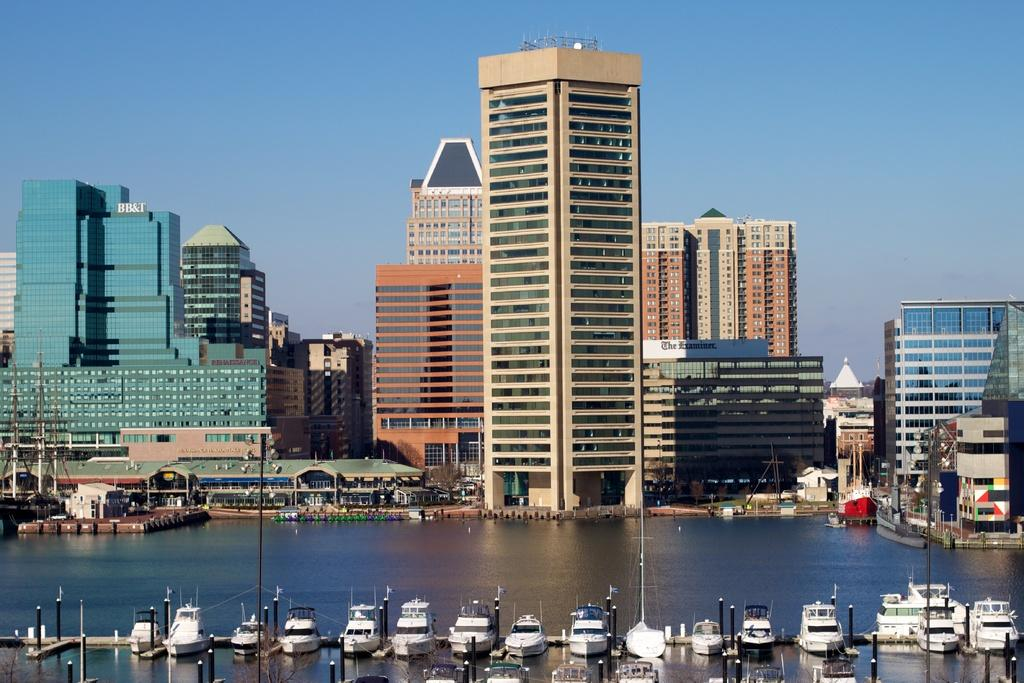What is on the water in the image? There are boats on the water in the image. What can be seen in the background of the image? There are buildings in the background. What type of windows do the buildings have? The buildings have glass windows. What color is the sky in the image? The sky is blue in the image. What type of flesh can be seen on the boats in the image? There is no flesh present on the boats in the image; they are inanimate objects. 